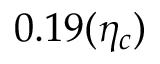<formula> <loc_0><loc_0><loc_500><loc_500>0 . 1 9 ( \eta _ { c } )</formula> 